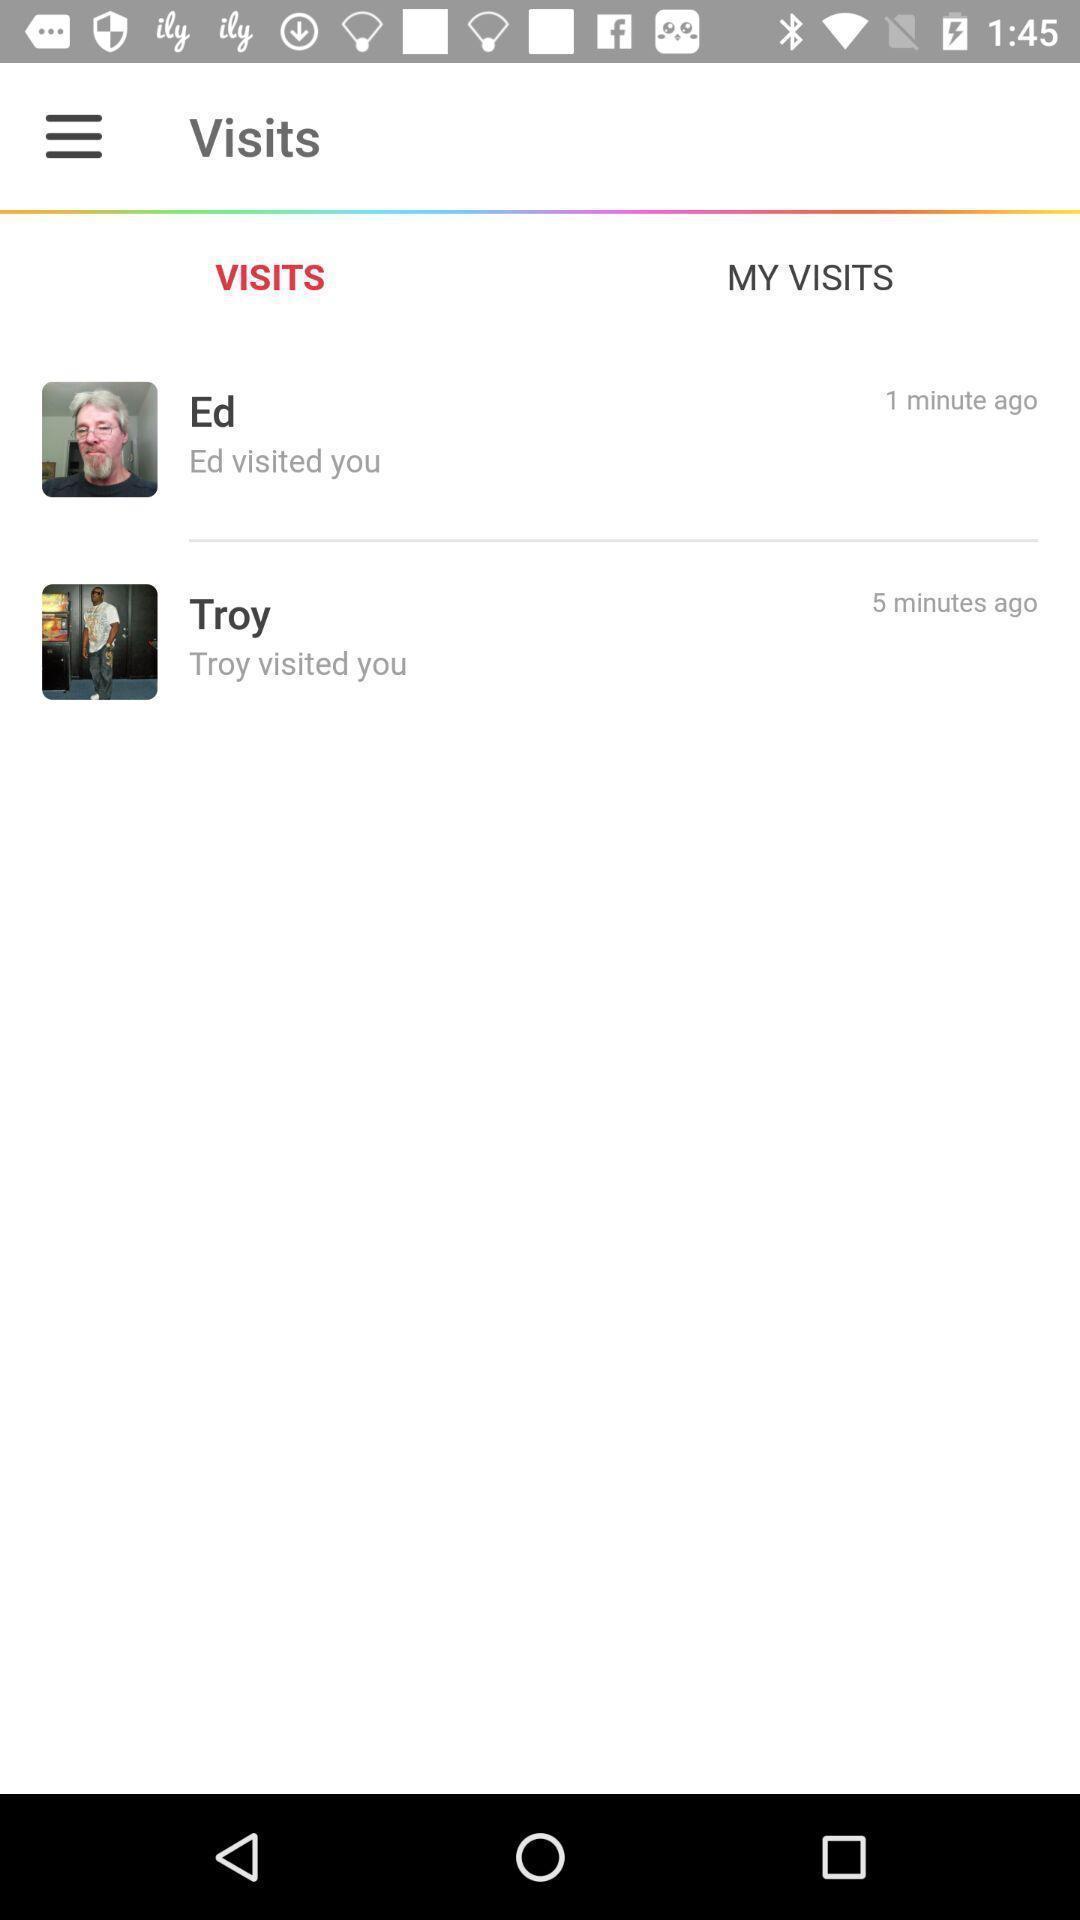Provide a description of this screenshot. Page displaying with profiles visited your account. 